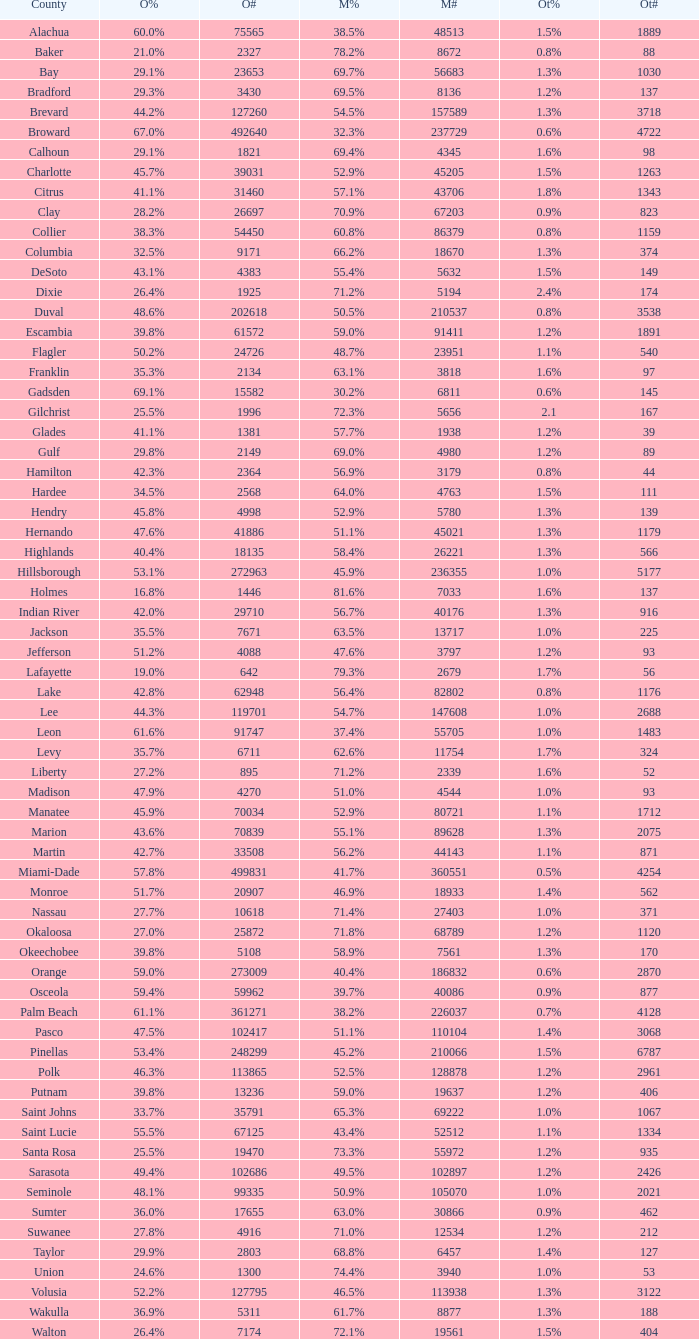What was the count of numbers recorded when obama had 29.9% voters? 1.0. Parse the full table. {'header': ['County', 'O%', 'O#', 'M%', 'M#', 'Ot%', 'Ot#'], 'rows': [['Alachua', '60.0%', '75565', '38.5%', '48513', '1.5%', '1889'], ['Baker', '21.0%', '2327', '78.2%', '8672', '0.8%', '88'], ['Bay', '29.1%', '23653', '69.7%', '56683', '1.3%', '1030'], ['Bradford', '29.3%', '3430', '69.5%', '8136', '1.2%', '137'], ['Brevard', '44.2%', '127260', '54.5%', '157589', '1.3%', '3718'], ['Broward', '67.0%', '492640', '32.3%', '237729', '0.6%', '4722'], ['Calhoun', '29.1%', '1821', '69.4%', '4345', '1.6%', '98'], ['Charlotte', '45.7%', '39031', '52.9%', '45205', '1.5%', '1263'], ['Citrus', '41.1%', '31460', '57.1%', '43706', '1.8%', '1343'], ['Clay', '28.2%', '26697', '70.9%', '67203', '0.9%', '823'], ['Collier', '38.3%', '54450', '60.8%', '86379', '0.8%', '1159'], ['Columbia', '32.5%', '9171', '66.2%', '18670', '1.3%', '374'], ['DeSoto', '43.1%', '4383', '55.4%', '5632', '1.5%', '149'], ['Dixie', '26.4%', '1925', '71.2%', '5194', '2.4%', '174'], ['Duval', '48.6%', '202618', '50.5%', '210537', '0.8%', '3538'], ['Escambia', '39.8%', '61572', '59.0%', '91411', '1.2%', '1891'], ['Flagler', '50.2%', '24726', '48.7%', '23951', '1.1%', '540'], ['Franklin', '35.3%', '2134', '63.1%', '3818', '1.6%', '97'], ['Gadsden', '69.1%', '15582', '30.2%', '6811', '0.6%', '145'], ['Gilchrist', '25.5%', '1996', '72.3%', '5656', '2.1', '167'], ['Glades', '41.1%', '1381', '57.7%', '1938', '1.2%', '39'], ['Gulf', '29.8%', '2149', '69.0%', '4980', '1.2%', '89'], ['Hamilton', '42.3%', '2364', '56.9%', '3179', '0.8%', '44'], ['Hardee', '34.5%', '2568', '64.0%', '4763', '1.5%', '111'], ['Hendry', '45.8%', '4998', '52.9%', '5780', '1.3%', '139'], ['Hernando', '47.6%', '41886', '51.1%', '45021', '1.3%', '1179'], ['Highlands', '40.4%', '18135', '58.4%', '26221', '1.3%', '566'], ['Hillsborough', '53.1%', '272963', '45.9%', '236355', '1.0%', '5177'], ['Holmes', '16.8%', '1446', '81.6%', '7033', '1.6%', '137'], ['Indian River', '42.0%', '29710', '56.7%', '40176', '1.3%', '916'], ['Jackson', '35.5%', '7671', '63.5%', '13717', '1.0%', '225'], ['Jefferson', '51.2%', '4088', '47.6%', '3797', '1.2%', '93'], ['Lafayette', '19.0%', '642', '79.3%', '2679', '1.7%', '56'], ['Lake', '42.8%', '62948', '56.4%', '82802', '0.8%', '1176'], ['Lee', '44.3%', '119701', '54.7%', '147608', '1.0%', '2688'], ['Leon', '61.6%', '91747', '37.4%', '55705', '1.0%', '1483'], ['Levy', '35.7%', '6711', '62.6%', '11754', '1.7%', '324'], ['Liberty', '27.2%', '895', '71.2%', '2339', '1.6%', '52'], ['Madison', '47.9%', '4270', '51.0%', '4544', '1.0%', '93'], ['Manatee', '45.9%', '70034', '52.9%', '80721', '1.1%', '1712'], ['Marion', '43.6%', '70839', '55.1%', '89628', '1.3%', '2075'], ['Martin', '42.7%', '33508', '56.2%', '44143', '1.1%', '871'], ['Miami-Dade', '57.8%', '499831', '41.7%', '360551', '0.5%', '4254'], ['Monroe', '51.7%', '20907', '46.9%', '18933', '1.4%', '562'], ['Nassau', '27.7%', '10618', '71.4%', '27403', '1.0%', '371'], ['Okaloosa', '27.0%', '25872', '71.8%', '68789', '1.2%', '1120'], ['Okeechobee', '39.8%', '5108', '58.9%', '7561', '1.3%', '170'], ['Orange', '59.0%', '273009', '40.4%', '186832', '0.6%', '2870'], ['Osceola', '59.4%', '59962', '39.7%', '40086', '0.9%', '877'], ['Palm Beach', '61.1%', '361271', '38.2%', '226037', '0.7%', '4128'], ['Pasco', '47.5%', '102417', '51.1%', '110104', '1.4%', '3068'], ['Pinellas', '53.4%', '248299', '45.2%', '210066', '1.5%', '6787'], ['Polk', '46.3%', '113865', '52.5%', '128878', '1.2%', '2961'], ['Putnam', '39.8%', '13236', '59.0%', '19637', '1.2%', '406'], ['Saint Johns', '33.7%', '35791', '65.3%', '69222', '1.0%', '1067'], ['Saint Lucie', '55.5%', '67125', '43.4%', '52512', '1.1%', '1334'], ['Santa Rosa', '25.5%', '19470', '73.3%', '55972', '1.2%', '935'], ['Sarasota', '49.4%', '102686', '49.5%', '102897', '1.2%', '2426'], ['Seminole', '48.1%', '99335', '50.9%', '105070', '1.0%', '2021'], ['Sumter', '36.0%', '17655', '63.0%', '30866', '0.9%', '462'], ['Suwanee', '27.8%', '4916', '71.0%', '12534', '1.2%', '212'], ['Taylor', '29.9%', '2803', '68.8%', '6457', '1.4%', '127'], ['Union', '24.6%', '1300', '74.4%', '3940', '1.0%', '53'], ['Volusia', '52.2%', '127795', '46.5%', '113938', '1.3%', '3122'], ['Wakulla', '36.9%', '5311', '61.7%', '8877', '1.3%', '188'], ['Walton', '26.4%', '7174', '72.1%', '19561', '1.5%', '404']]} 